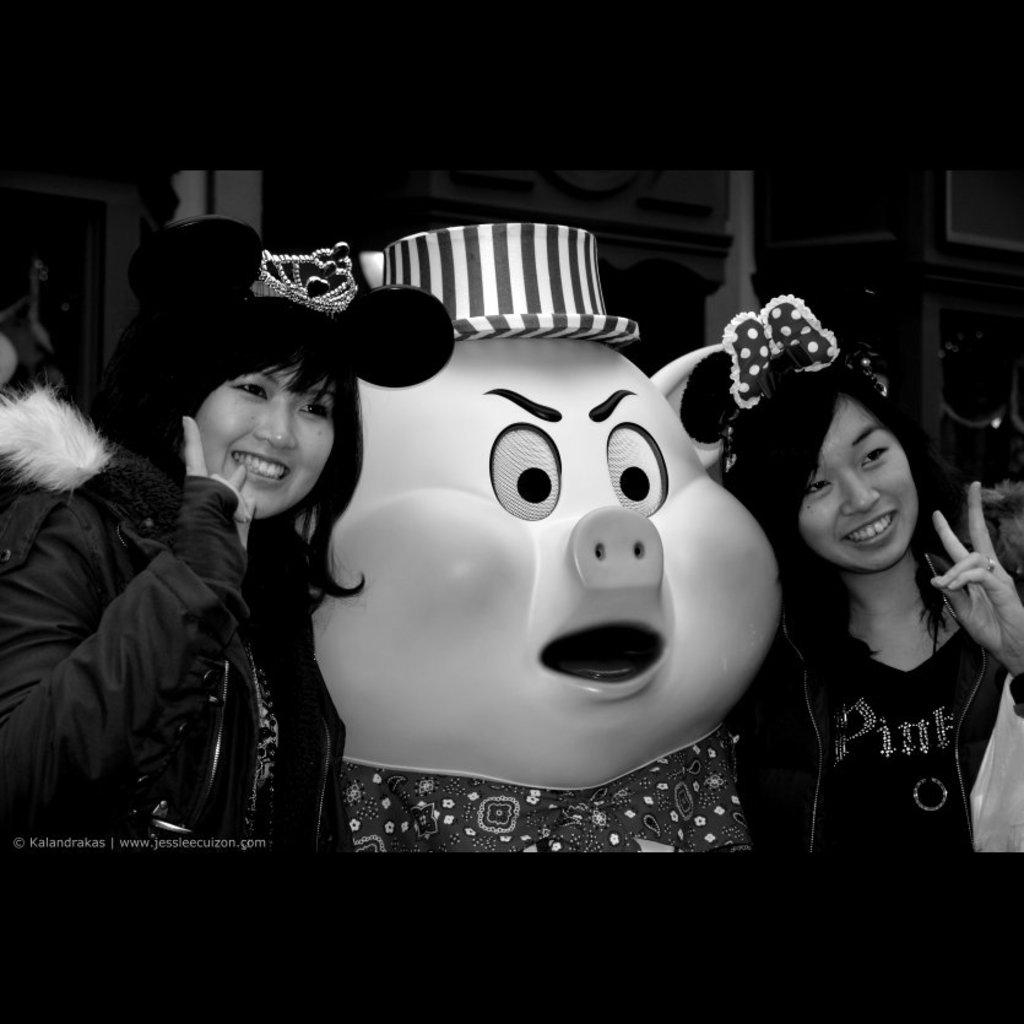What is the main subject in the middle of the image? There is a doll in the shape of a pig in the middle of the image. Who is surrounding the doll in the image? Two girls are present on either side of the doll. What is the facial expression of the girls in the image? The girls are smiling. What type of headwear are the girls wearing in the image? The girls are wearing caps. Where is the vase placed in the image? There is no vase present in the image. What type of furniture is the servant sitting on in the image? There is no servant or furniture present in the image. 